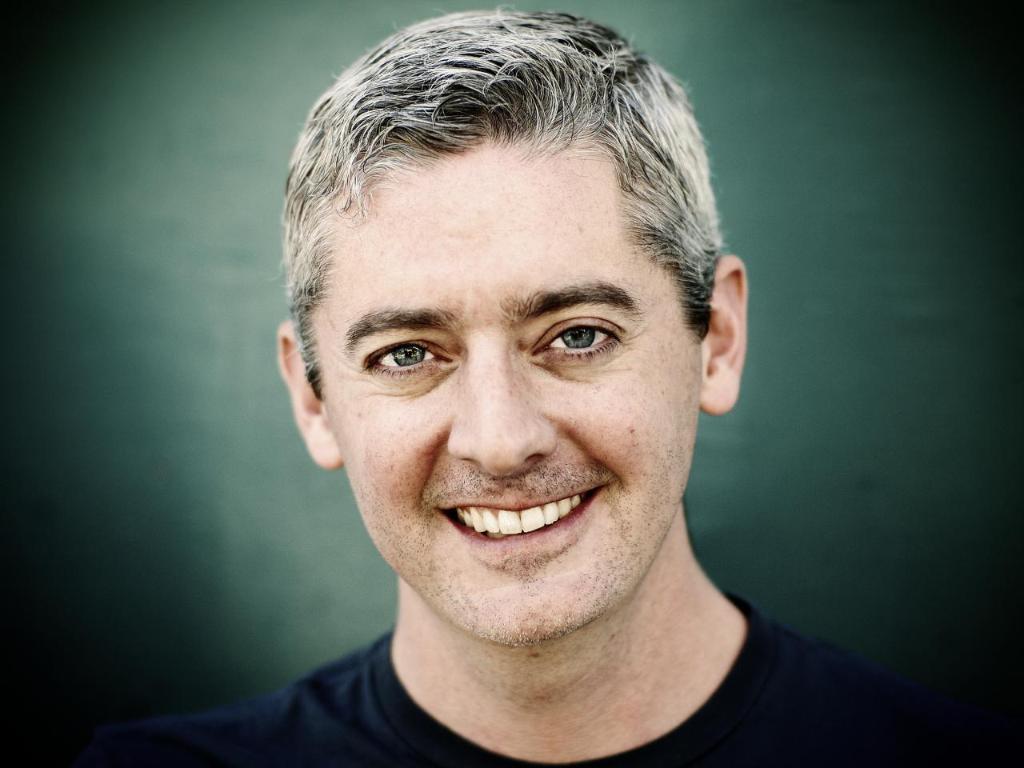Describe this image in one or two sentences. In this image, I can see the man smiling. He wore a black T-shirt. The background looks dark green in color. 